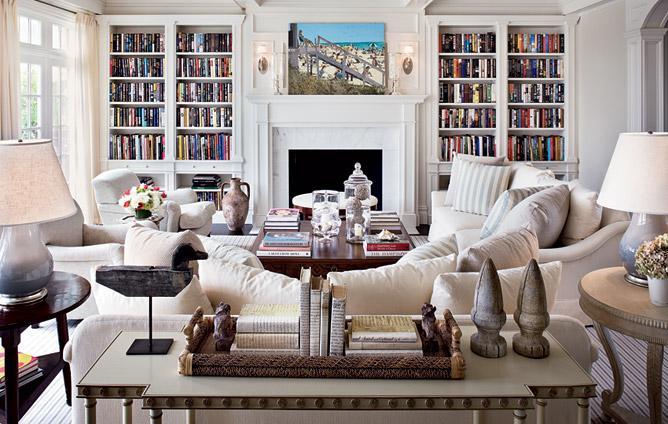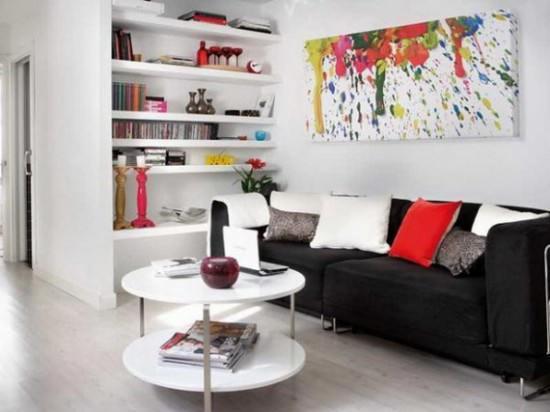The first image is the image on the left, the second image is the image on the right. Assess this claim about the two images: "One image shows bookcases lining the left and right walls, with a floor between.". Correct or not? Answer yes or no. No. 